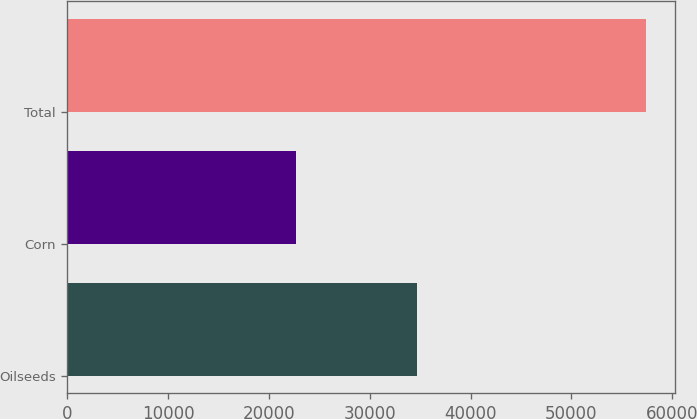<chart> <loc_0><loc_0><loc_500><loc_500><bar_chart><fcel>Oilseeds<fcel>Corn<fcel>Total<nl><fcel>34733<fcel>22700<fcel>57433<nl></chart> 